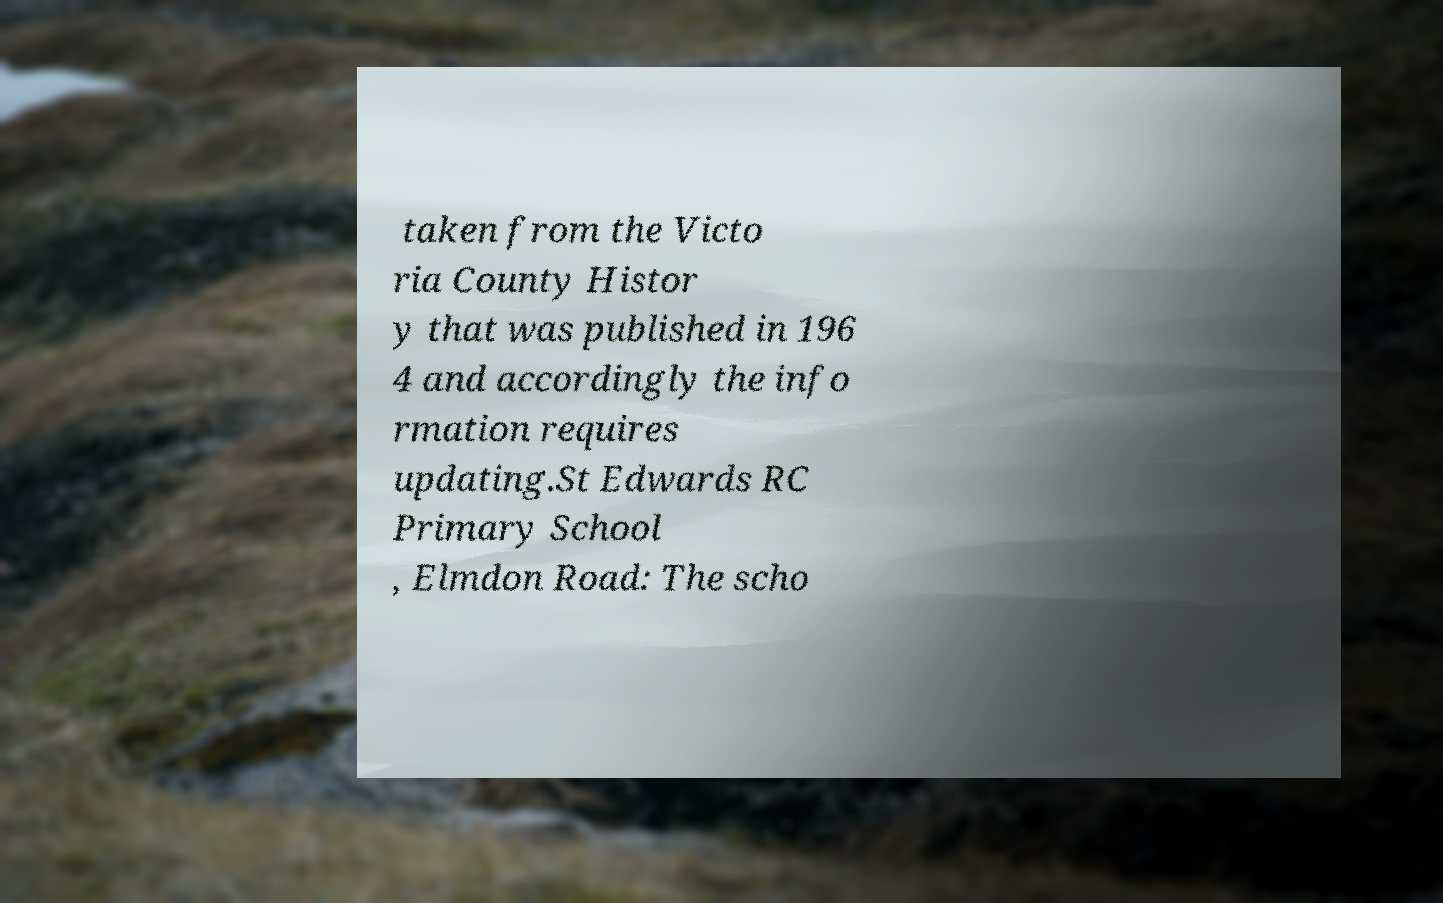There's text embedded in this image that I need extracted. Can you transcribe it verbatim? taken from the Victo ria County Histor y that was published in 196 4 and accordingly the info rmation requires updating.St Edwards RC Primary School , Elmdon Road: The scho 